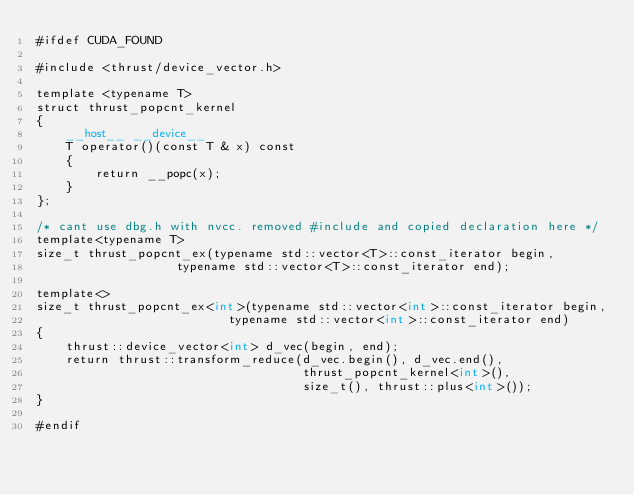<code> <loc_0><loc_0><loc_500><loc_500><_Cuda_>#ifdef CUDA_FOUND

#include <thrust/device_vector.h>

template <typename T>
struct thrust_popcnt_kernel
{
    __host__ __device__
    T operator()(const T & x) const
    {
        return __popc(x);
    }
};

/* cant use dbg.h with nvcc. removed #include and copied declaration here */
template<typename T>
size_t thrust_popcnt_ex(typename std::vector<T>::const_iterator begin,
                   typename std::vector<T>::const_iterator end);

template<>
size_t thrust_popcnt_ex<int>(typename std::vector<int>::const_iterator begin,
                          typename std::vector<int>::const_iterator end)
{
    thrust::device_vector<int> d_vec(begin, end);
    return thrust::transform_reduce(d_vec.begin(), d_vec.end(),
                                    thrust_popcnt_kernel<int>(),
                                    size_t(), thrust::plus<int>());
}

#endif
</code> 